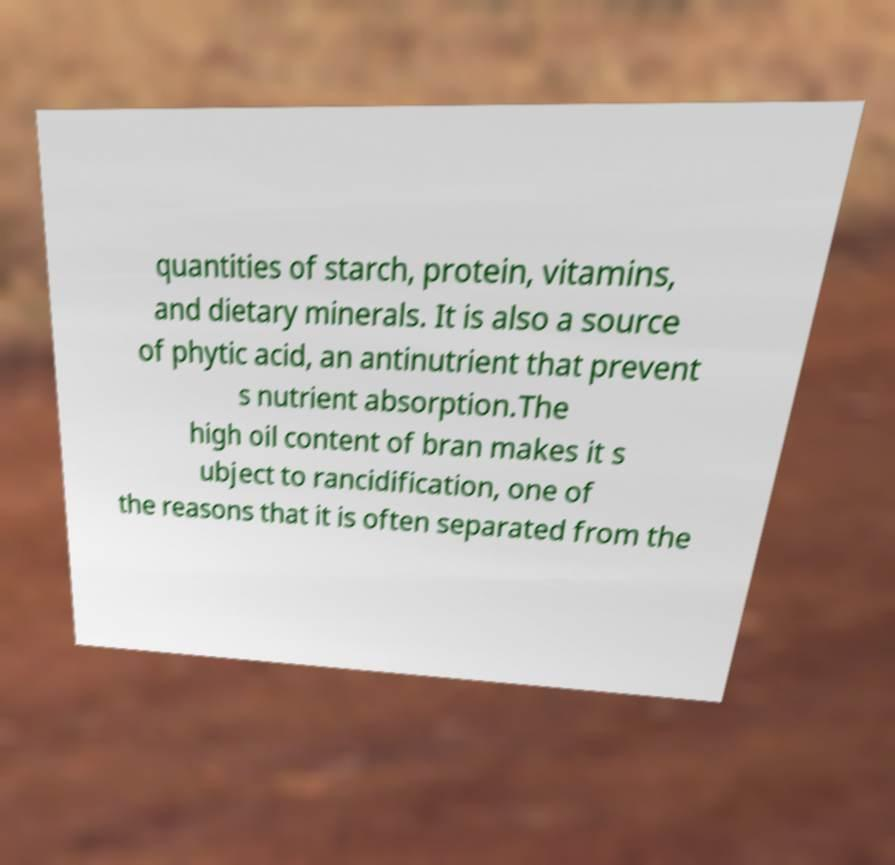There's text embedded in this image that I need extracted. Can you transcribe it verbatim? quantities of starch, protein, vitamins, and dietary minerals. It is also a source of phytic acid, an antinutrient that prevent s nutrient absorption.The high oil content of bran makes it s ubject to rancidification, one of the reasons that it is often separated from the 